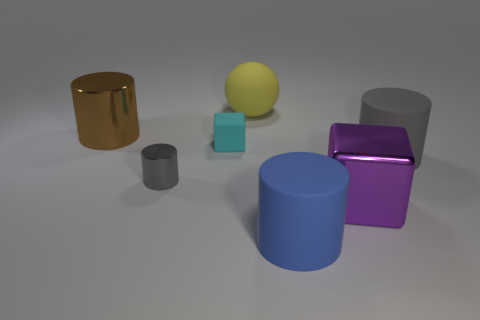Is there a brown shiny cylinder of the same size as the rubber sphere?
Your answer should be compact. Yes. Is the number of big matte objects that are in front of the cyan matte cube greater than the number of green shiny balls?
Provide a succinct answer. Yes. How many small things are purple shiny blocks or blue cylinders?
Your answer should be compact. 0. What number of other big objects are the same shape as the big purple metal thing?
Provide a succinct answer. 0. What is the material of the big purple thing that is to the right of the tiny thing that is on the left side of the tiny matte thing?
Keep it short and to the point. Metal. What is the size of the cube that is left of the big yellow thing?
Keep it short and to the point. Small. How many yellow things are either metal objects or large blocks?
Your response must be concise. 0. What is the material of the tiny gray thing that is the same shape as the big blue rubber thing?
Keep it short and to the point. Metal. Are there the same number of yellow balls that are left of the gray shiny thing and large matte objects?
Provide a succinct answer. No. What size is the metal thing that is both on the left side of the yellow matte object and right of the brown object?
Give a very brief answer. Small. 